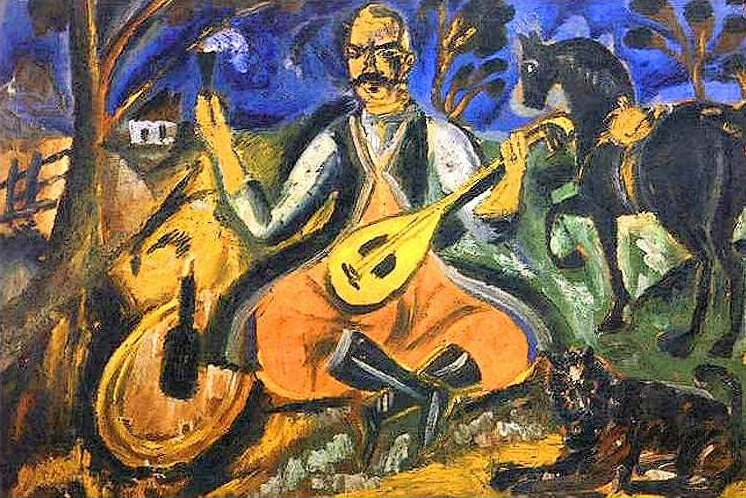Can you describe the significance of the twilight setting in this painting? The twilight setting enhances the mood of solitude and contemplation. The fading light often symbolizes the end of a day and can be seen as a metaphor for reflection or change. In this context, it could also emphasize the timeless beauty of the rural life and the enduring nature of art and personal expression. 